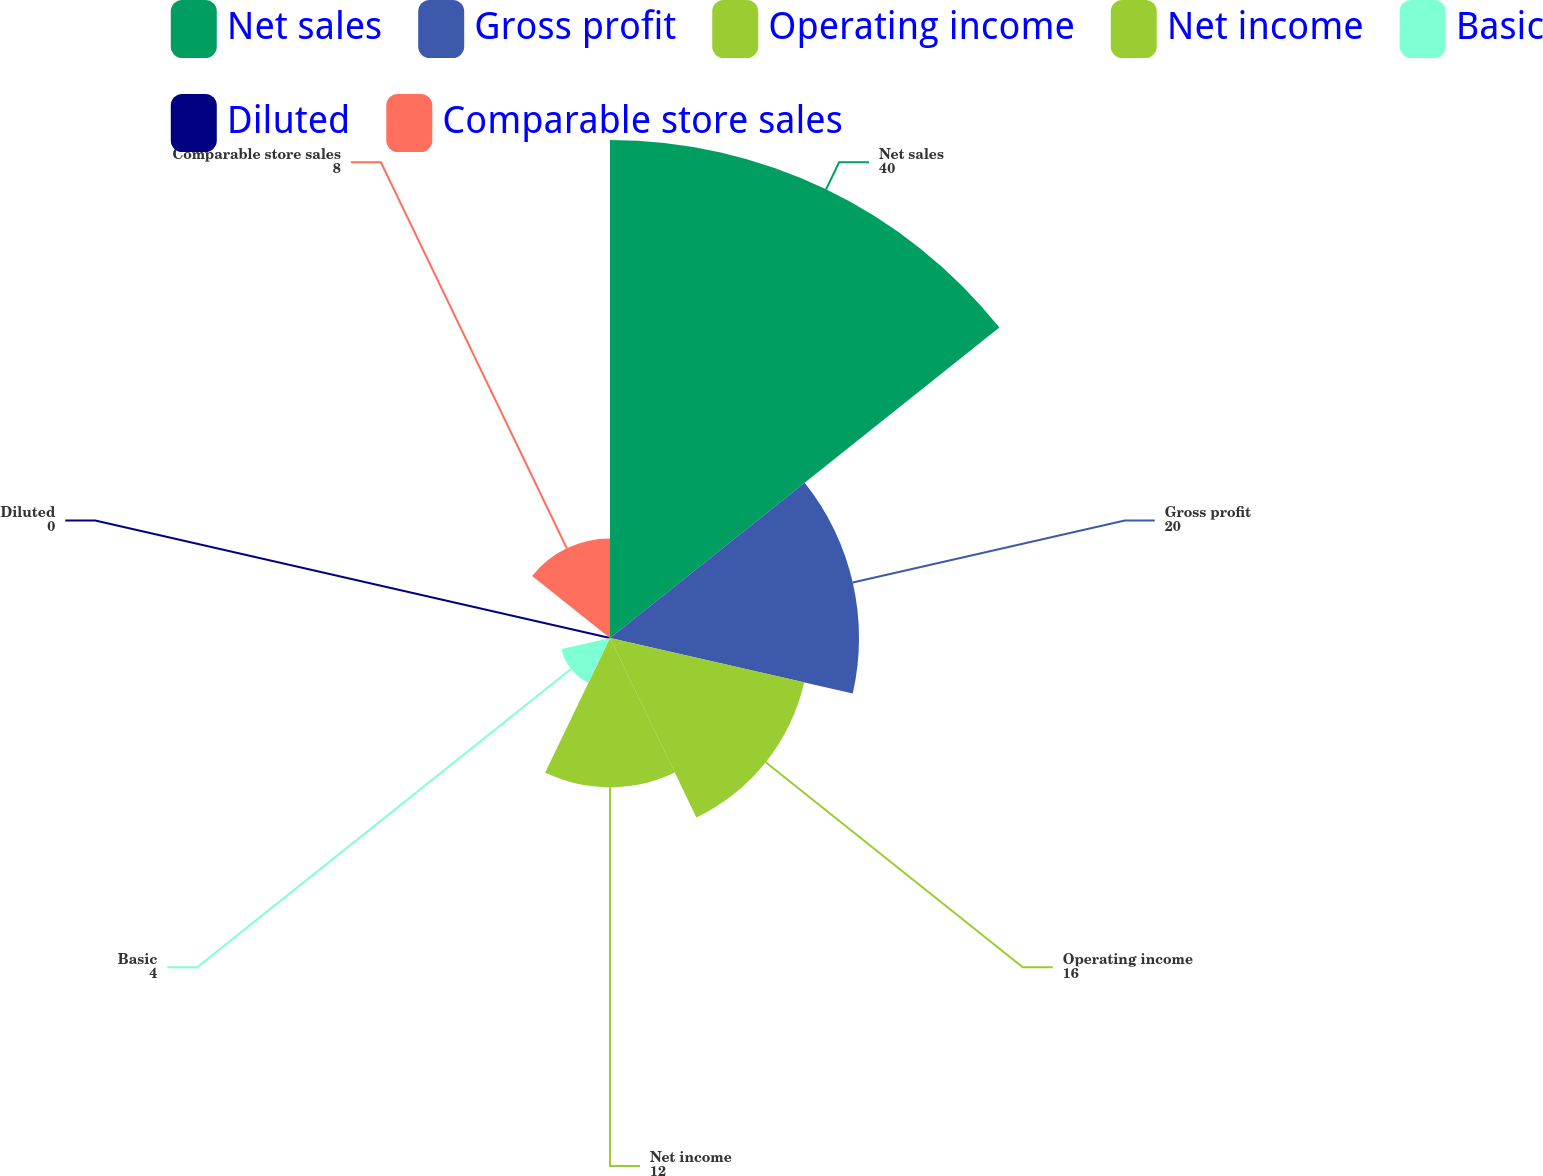Convert chart. <chart><loc_0><loc_0><loc_500><loc_500><pie_chart><fcel>Net sales<fcel>Gross profit<fcel>Operating income<fcel>Net income<fcel>Basic<fcel>Diluted<fcel>Comparable store sales<nl><fcel>40.0%<fcel>20.0%<fcel>16.0%<fcel>12.0%<fcel>4.0%<fcel>0.0%<fcel>8.0%<nl></chart> 